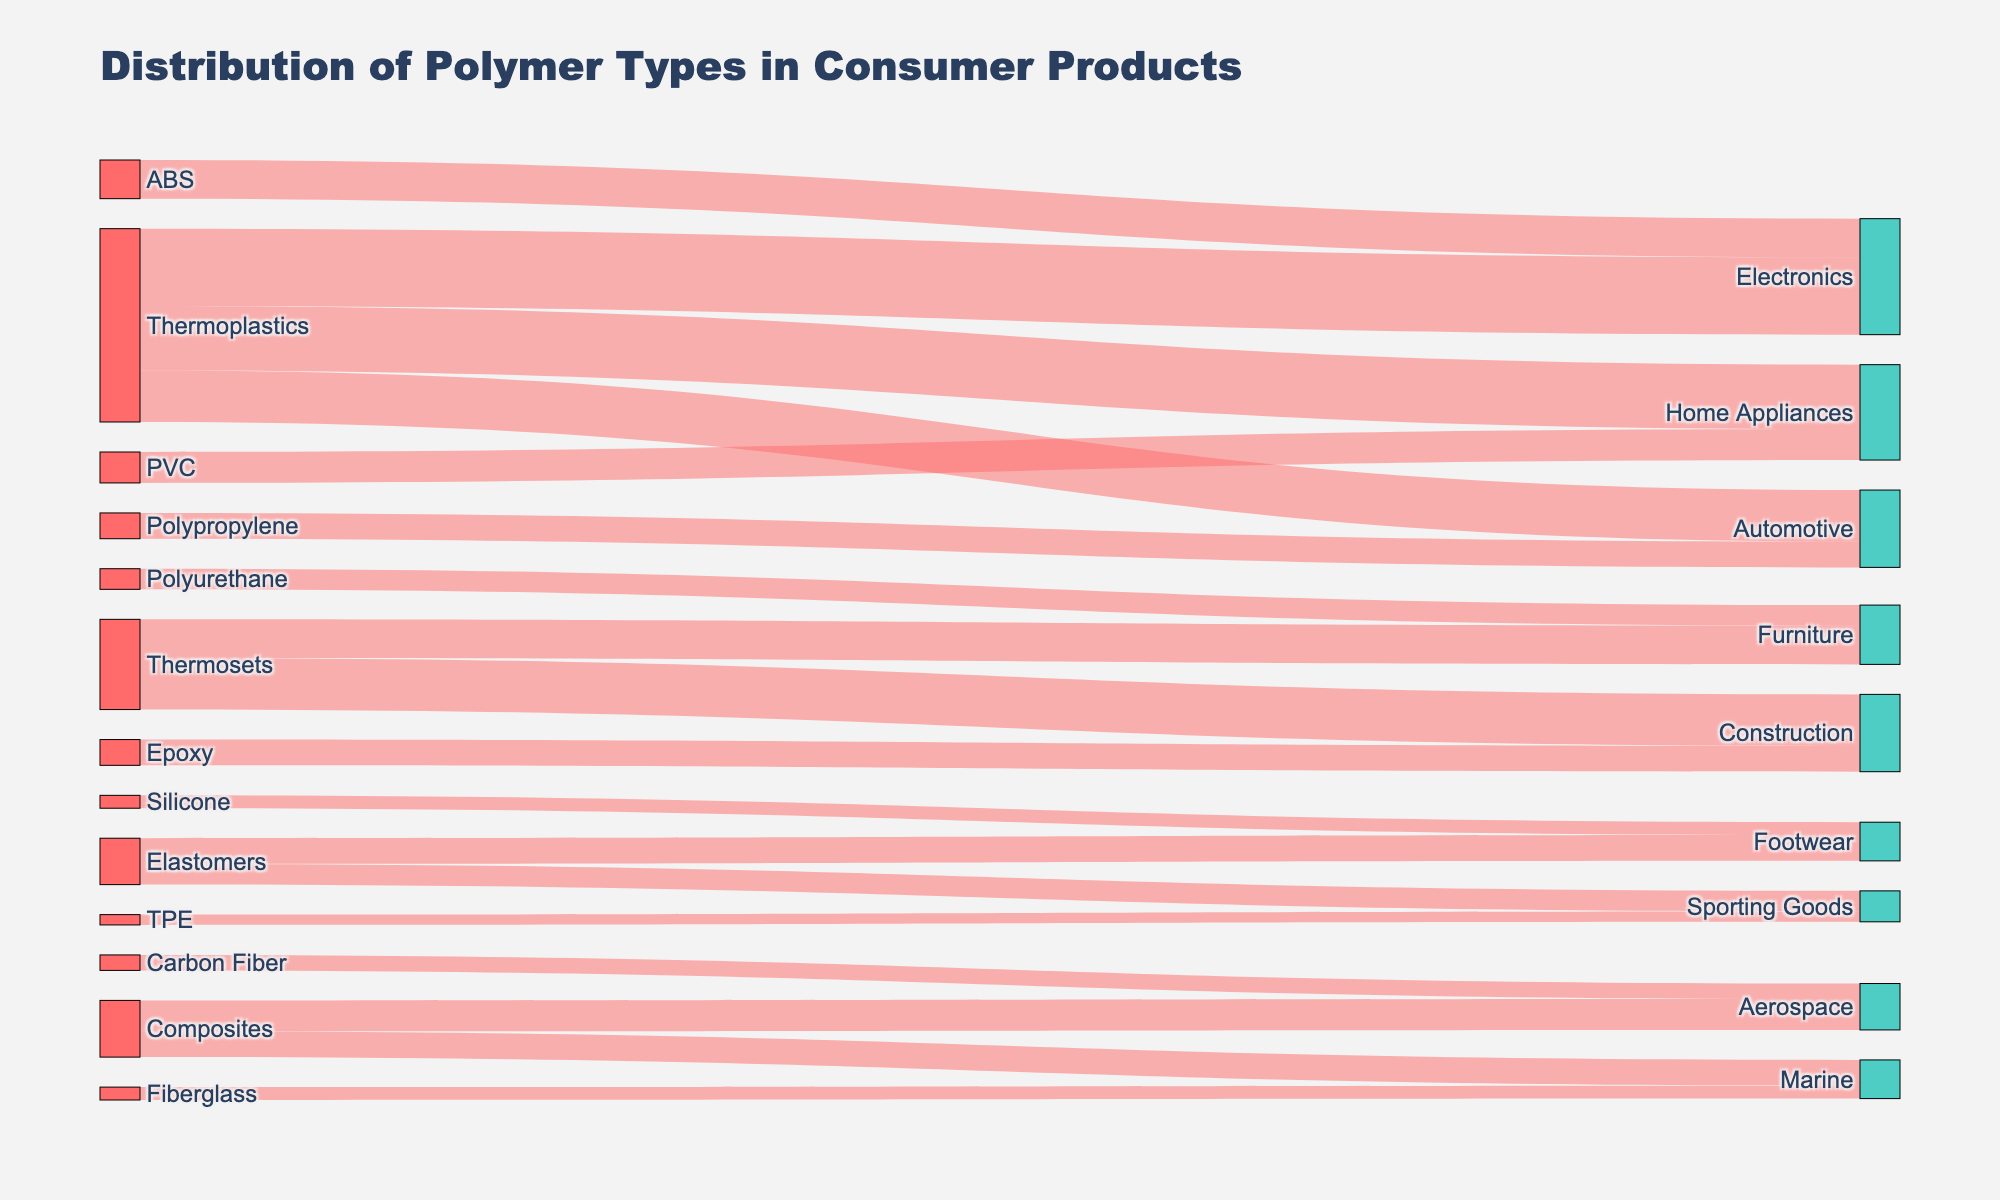what is the title of the Sankey diagram? The title is centered at the top in large, bold font, indicating the topic of the Sankey diagram.
Answer: Distribution of Polymer Types in Consumer Products What category does Thermoplastics contribute the most to? Look at the nodes connected to Thermoplastics and find the thickest link, which represents the highest value.
Answer: Electronics What material is primarily used in Aerospace products? Identify the node labeled Aerospace and see which node it's connected to with the thickest link.
Answer: Carbon Fiber What is the combined value of Thermoplastics contributing to both Electronics and Home Appliances? Sum the values of the links from Thermoplastics to Electronics and Home Appliances (30 + 25).
Answer: 55 How does the value of Thermosets in Construction compare to Thermosets in Furniture? Compare the values of links leading from Thermosets to Construction and Thermosets to Furniture.
Answer: Construction (20) has a higher value than Furniture (15) Which product category has the least contribution from Elastomers? Identify the links from Elastomers and compare their values.
Answer: Sporting Goods What is the total value contributed by all types of Composites? Add the values of the links originating from Composites (12 + 10).
Answer: 22 Which polymer has the highest contribution to Home Appliances? Locate the Home Appliances node and identify the link with the highest value connected to it.
Answer: PVC Are there any polymers that are used exclusively in a single product category? If so, name one. Identify nodes connected by only one link and name any polymer with such a connection.
Answer: Polyurethane (Furniture) What percentage of Thermoplastics is used in Automotive, rounded to the nearest whole number? Divide the value of Thermoplastics in Automotive by the total value of Thermoplastics (20 / (30 + 25 + 20) * 100)
Answer: 24% 